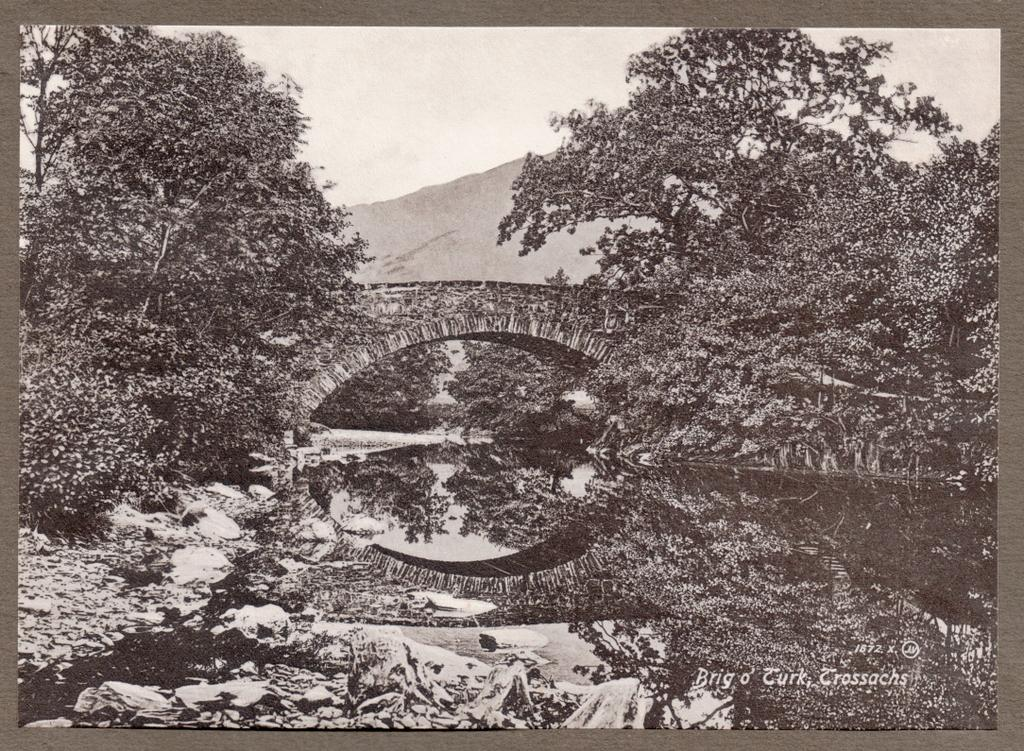What is the color scheme of the image? The image is black and white. What can be seen at the bottom of the image? There is water visible at the bottom of the image. Where are the trees located in the image? There are trees on both the left and right sides of the image. What is visible in the background of the image? In the background, there is a bridge, trees, a mountain, and the sky. What type of nerve can be seen in the image? There are no nerves present in the image; it is a black and white landscape featuring water, trees, a bridge, a mountain, and the sky. 